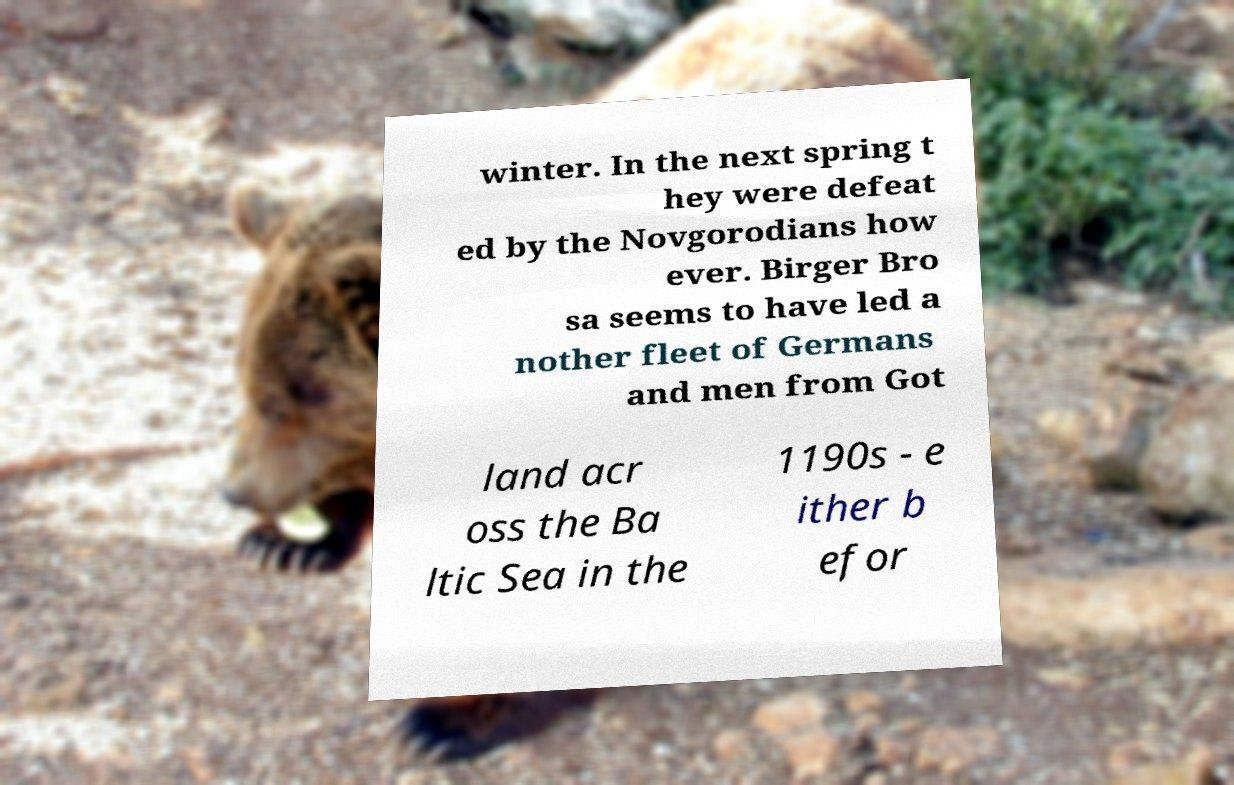Please read and relay the text visible in this image. What does it say? winter. In the next spring t hey were defeat ed by the Novgorodians how ever. Birger Bro sa seems to have led a nother fleet of Germans and men from Got land acr oss the Ba ltic Sea in the 1190s - e ither b efor 